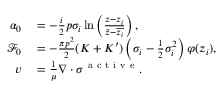<formula> <loc_0><loc_0><loc_500><loc_500>\begin{array} { r l } { \alpha _ { 0 } } & = - \frac { i } { 2 } p \sigma _ { i } \ln \left ( \frac { z - z _ { i } } { \bar { z } - \overline { { z _ { i } } } } \right ) , } \\ { \mathcal { F } _ { 0 } } & = - \frac { \pi p ^ { 2 } } { 2 } ( K + K ^ { \prime } ) \left ( \sigma _ { i } - \frac { 1 } { 2 } \sigma _ { i } ^ { 2 } \right ) \varphi ( z _ { i } ) , } \\ { v } & = \frac { 1 } { \mu } \nabla \cdot \sigma ^ { a c t i v e } . } \end{array}</formula> 